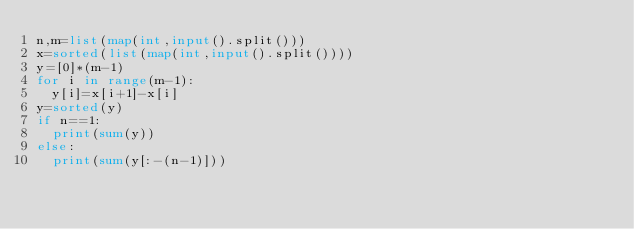Convert code to text. <code><loc_0><loc_0><loc_500><loc_500><_Python_>n,m=list(map(int,input().split()))
x=sorted(list(map(int,input().split())))
y=[0]*(m-1)
for i in range(m-1):
  y[i]=x[i+1]-x[i]
y=sorted(y)
if n==1:
  print(sum(y))
else:
  print(sum(y[:-(n-1)]))</code> 